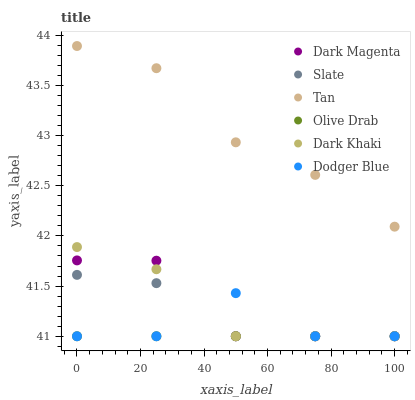Does Olive Drab have the minimum area under the curve?
Answer yes or no. Yes. Does Tan have the maximum area under the curve?
Answer yes or no. Yes. Does Slate have the minimum area under the curve?
Answer yes or no. No. Does Slate have the maximum area under the curve?
Answer yes or no. No. Is Olive Drab the smoothest?
Answer yes or no. Yes. Is Dodger Blue the roughest?
Answer yes or no. Yes. Is Slate the smoothest?
Answer yes or no. No. Is Slate the roughest?
Answer yes or no. No. Does Dark Magenta have the lowest value?
Answer yes or no. Yes. Does Tan have the lowest value?
Answer yes or no. No. Does Tan have the highest value?
Answer yes or no. Yes. Does Slate have the highest value?
Answer yes or no. No. Is Dark Khaki less than Tan?
Answer yes or no. Yes. Is Tan greater than Slate?
Answer yes or no. Yes. Does Olive Drab intersect Dark Khaki?
Answer yes or no. Yes. Is Olive Drab less than Dark Khaki?
Answer yes or no. No. Is Olive Drab greater than Dark Khaki?
Answer yes or no. No. Does Dark Khaki intersect Tan?
Answer yes or no. No. 